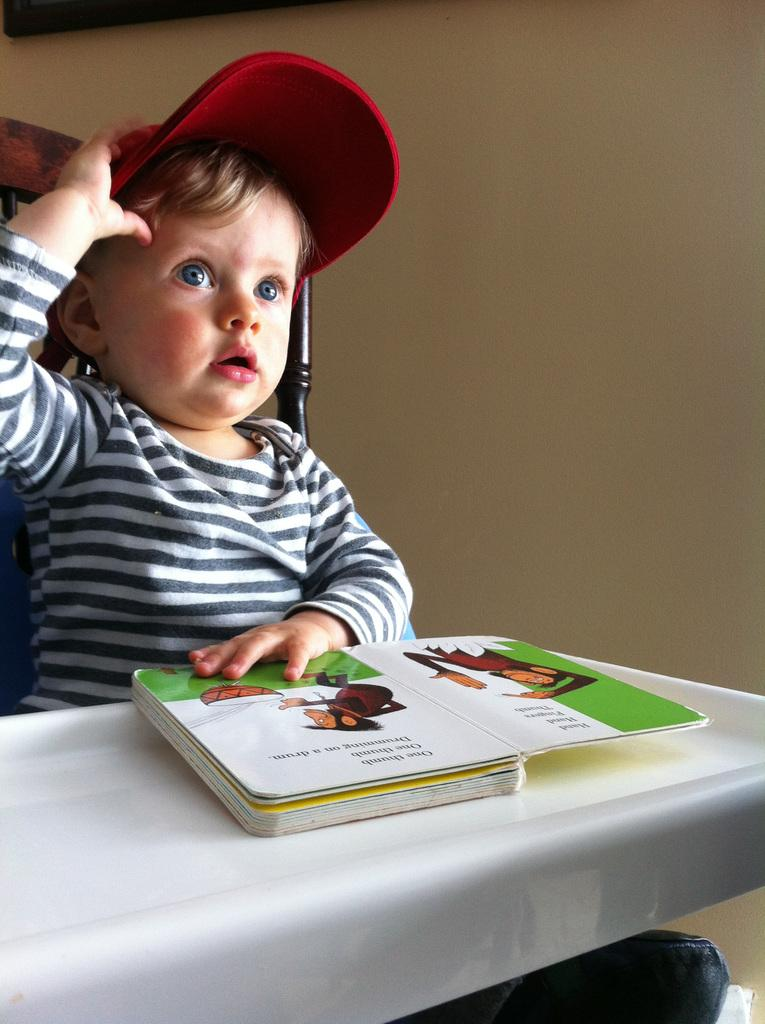What is the main subject of the image? There is a baby in the image. What is the baby doing in the image? The baby is sitting in a chair. What is the baby wearing in the image? The baby is wearing a cap. What can be seen on the table in the image? A book is placed on the table. What is visible in the background of the image? There is a wall in the background of the image. What type of toe is visible on the baby's foot in the image? There is no toe visible on the baby's foot in the image. What kind of music can be heard playing in the background of the image? There is no music present in the image; it is a still photograph. 